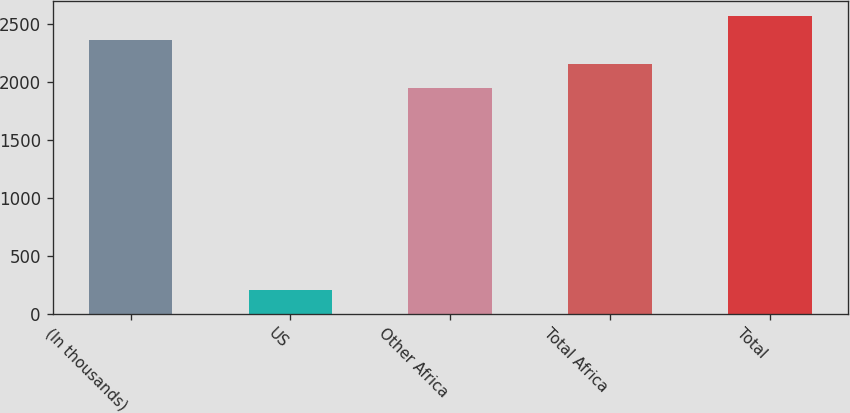Convert chart to OTSL. <chart><loc_0><loc_0><loc_500><loc_500><bar_chart><fcel>(In thousands)<fcel>US<fcel>Other Africa<fcel>Total Africa<fcel>Total<nl><fcel>2364.8<fcel>211<fcel>1950<fcel>2157.4<fcel>2572.2<nl></chart> 